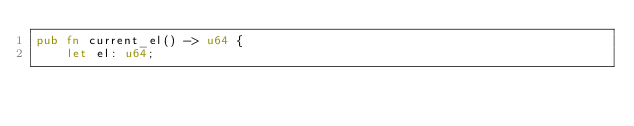Convert code to text. <code><loc_0><loc_0><loc_500><loc_500><_Rust_>pub fn current_el() -> u64 {
    let el: u64;
</code> 